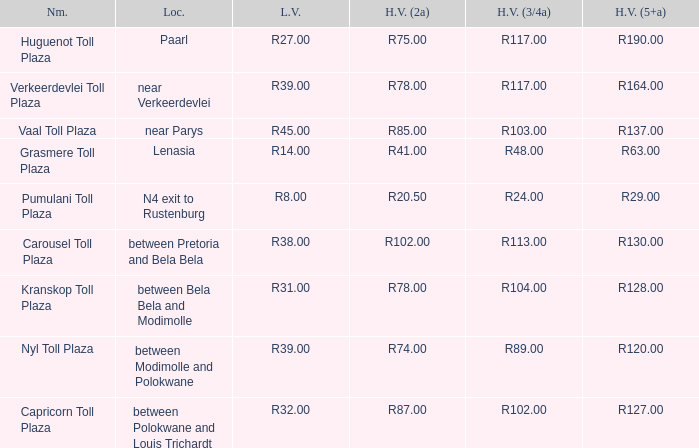50? Pumulani Toll Plaza. 